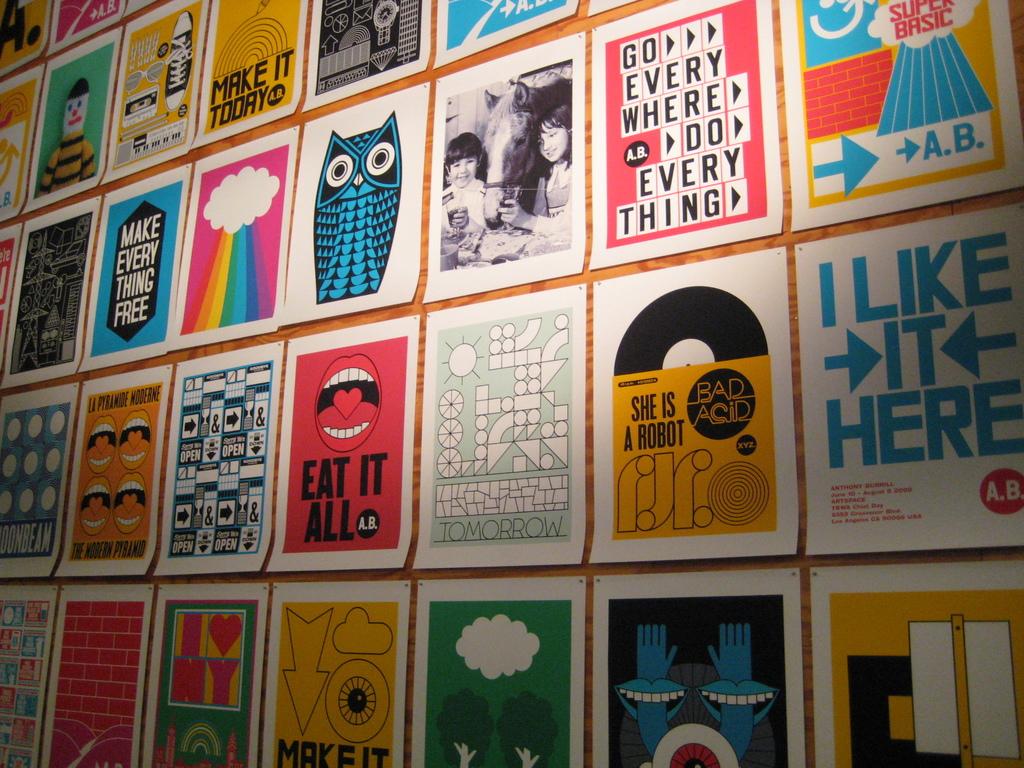What does the poster with the open mouth say?
Offer a very short reply. Eat it all. What quote is linked to the red mouth?
Your answer should be compact. Eat it all. 